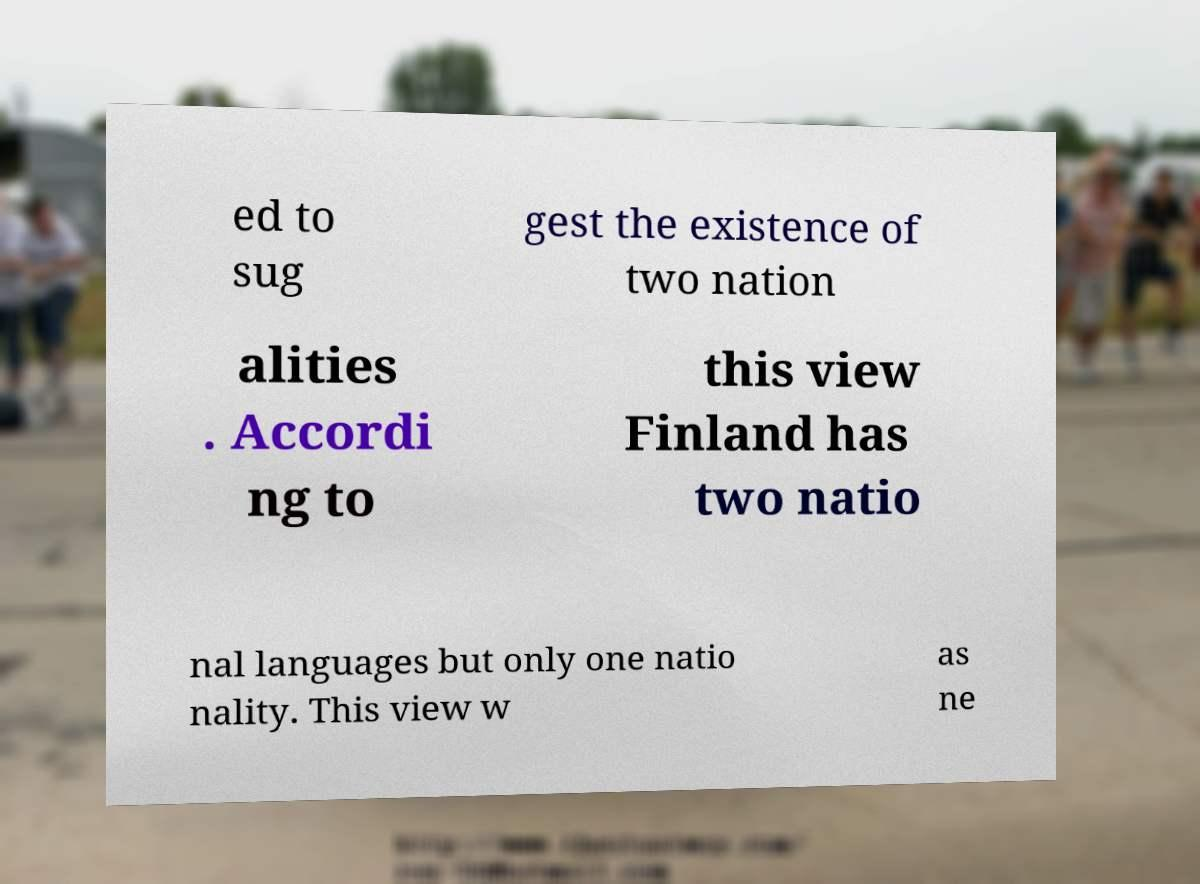Can you accurately transcribe the text from the provided image for me? ed to sug gest the existence of two nation alities . Accordi ng to this view Finland has two natio nal languages but only one natio nality. This view w as ne 